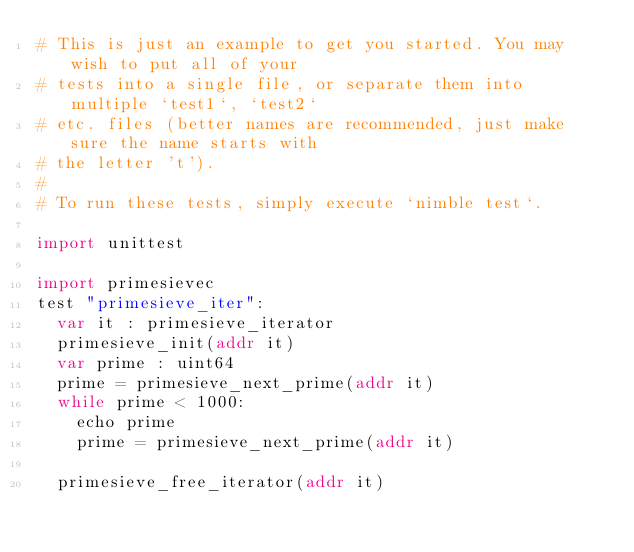Convert code to text. <code><loc_0><loc_0><loc_500><loc_500><_Nim_># This is just an example to get you started. You may wish to put all of your
# tests into a single file, or separate them into multiple `test1`, `test2`
# etc. files (better names are recommended, just make sure the name starts with
# the letter 't').
#
# To run these tests, simply execute `nimble test`.

import unittest

import primesievec
test "primesieve_iter":
  var it : primesieve_iterator
  primesieve_init(addr it)
  var prime : uint64
  prime = primesieve_next_prime(addr it)
  while prime < 1000:
    echo prime
    prime = primesieve_next_prime(addr it)

  primesieve_free_iterator(addr it)


</code> 